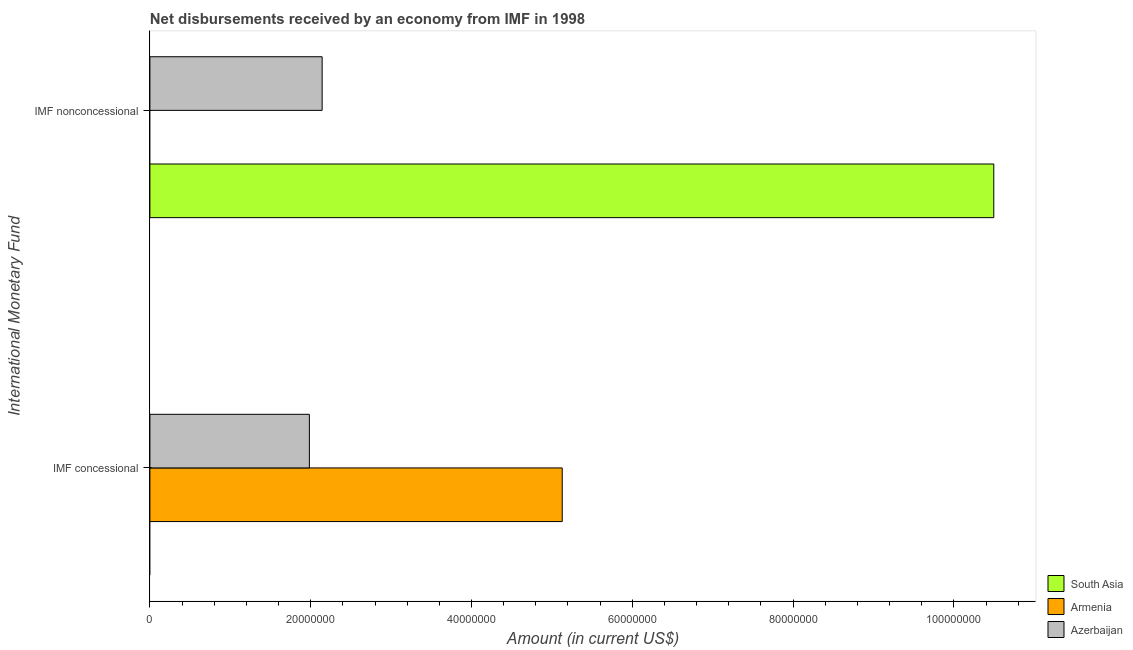How many different coloured bars are there?
Keep it short and to the point. 3. How many groups of bars are there?
Give a very brief answer. 2. Are the number of bars per tick equal to the number of legend labels?
Offer a very short reply. No. How many bars are there on the 1st tick from the bottom?
Keep it short and to the point. 2. What is the label of the 2nd group of bars from the top?
Your response must be concise. IMF concessional. What is the net concessional disbursements from imf in Armenia?
Your response must be concise. 5.13e+07. Across all countries, what is the maximum net concessional disbursements from imf?
Provide a short and direct response. 5.13e+07. In which country was the net non concessional disbursements from imf maximum?
Provide a short and direct response. South Asia. What is the total net concessional disbursements from imf in the graph?
Your response must be concise. 7.11e+07. What is the difference between the net concessional disbursements from imf in Azerbaijan and that in Armenia?
Ensure brevity in your answer.  -3.14e+07. What is the difference between the net concessional disbursements from imf in Azerbaijan and the net non concessional disbursements from imf in South Asia?
Your response must be concise. -8.51e+07. What is the average net concessional disbursements from imf per country?
Keep it short and to the point. 2.37e+07. What is the difference between the net concessional disbursements from imf and net non concessional disbursements from imf in Azerbaijan?
Give a very brief answer. -1.59e+06. In how many countries, is the net concessional disbursements from imf greater than 104000000 US$?
Provide a succinct answer. 0. In how many countries, is the net non concessional disbursements from imf greater than the average net non concessional disbursements from imf taken over all countries?
Provide a short and direct response. 1. Are all the bars in the graph horizontal?
Offer a terse response. Yes. How many countries are there in the graph?
Your answer should be very brief. 3. What is the difference between two consecutive major ticks on the X-axis?
Keep it short and to the point. 2.00e+07. Does the graph contain grids?
Ensure brevity in your answer.  No. Where does the legend appear in the graph?
Offer a very short reply. Bottom right. How many legend labels are there?
Give a very brief answer. 3. What is the title of the graph?
Keep it short and to the point. Net disbursements received by an economy from IMF in 1998. Does "Tunisia" appear as one of the legend labels in the graph?
Keep it short and to the point. No. What is the label or title of the X-axis?
Offer a very short reply. Amount (in current US$). What is the label or title of the Y-axis?
Provide a short and direct response. International Monetary Fund. What is the Amount (in current US$) in South Asia in IMF concessional?
Give a very brief answer. 0. What is the Amount (in current US$) in Armenia in IMF concessional?
Give a very brief answer. 5.13e+07. What is the Amount (in current US$) of Azerbaijan in IMF concessional?
Provide a succinct answer. 1.98e+07. What is the Amount (in current US$) of South Asia in IMF nonconcessional?
Your response must be concise. 1.05e+08. What is the Amount (in current US$) in Azerbaijan in IMF nonconcessional?
Your response must be concise. 2.14e+07. Across all International Monetary Fund, what is the maximum Amount (in current US$) of South Asia?
Provide a short and direct response. 1.05e+08. Across all International Monetary Fund, what is the maximum Amount (in current US$) in Armenia?
Offer a very short reply. 5.13e+07. Across all International Monetary Fund, what is the maximum Amount (in current US$) in Azerbaijan?
Your answer should be compact. 2.14e+07. Across all International Monetary Fund, what is the minimum Amount (in current US$) of Azerbaijan?
Offer a terse response. 1.98e+07. What is the total Amount (in current US$) in South Asia in the graph?
Give a very brief answer. 1.05e+08. What is the total Amount (in current US$) in Armenia in the graph?
Keep it short and to the point. 5.13e+07. What is the total Amount (in current US$) of Azerbaijan in the graph?
Offer a very short reply. 4.13e+07. What is the difference between the Amount (in current US$) of Azerbaijan in IMF concessional and that in IMF nonconcessional?
Make the answer very short. -1.59e+06. What is the difference between the Amount (in current US$) of Armenia in IMF concessional and the Amount (in current US$) of Azerbaijan in IMF nonconcessional?
Your response must be concise. 2.99e+07. What is the average Amount (in current US$) in South Asia per International Monetary Fund?
Make the answer very short. 5.25e+07. What is the average Amount (in current US$) of Armenia per International Monetary Fund?
Your response must be concise. 2.56e+07. What is the average Amount (in current US$) in Azerbaijan per International Monetary Fund?
Make the answer very short. 2.06e+07. What is the difference between the Amount (in current US$) in Armenia and Amount (in current US$) in Azerbaijan in IMF concessional?
Keep it short and to the point. 3.14e+07. What is the difference between the Amount (in current US$) in South Asia and Amount (in current US$) in Azerbaijan in IMF nonconcessional?
Your response must be concise. 8.35e+07. What is the ratio of the Amount (in current US$) of Azerbaijan in IMF concessional to that in IMF nonconcessional?
Make the answer very short. 0.93. What is the difference between the highest and the second highest Amount (in current US$) in Azerbaijan?
Offer a terse response. 1.59e+06. What is the difference between the highest and the lowest Amount (in current US$) of South Asia?
Offer a very short reply. 1.05e+08. What is the difference between the highest and the lowest Amount (in current US$) in Armenia?
Ensure brevity in your answer.  5.13e+07. What is the difference between the highest and the lowest Amount (in current US$) in Azerbaijan?
Offer a terse response. 1.59e+06. 